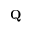Convert formula to latex. <formula><loc_0><loc_0><loc_500><loc_500>{ Q }</formula> 